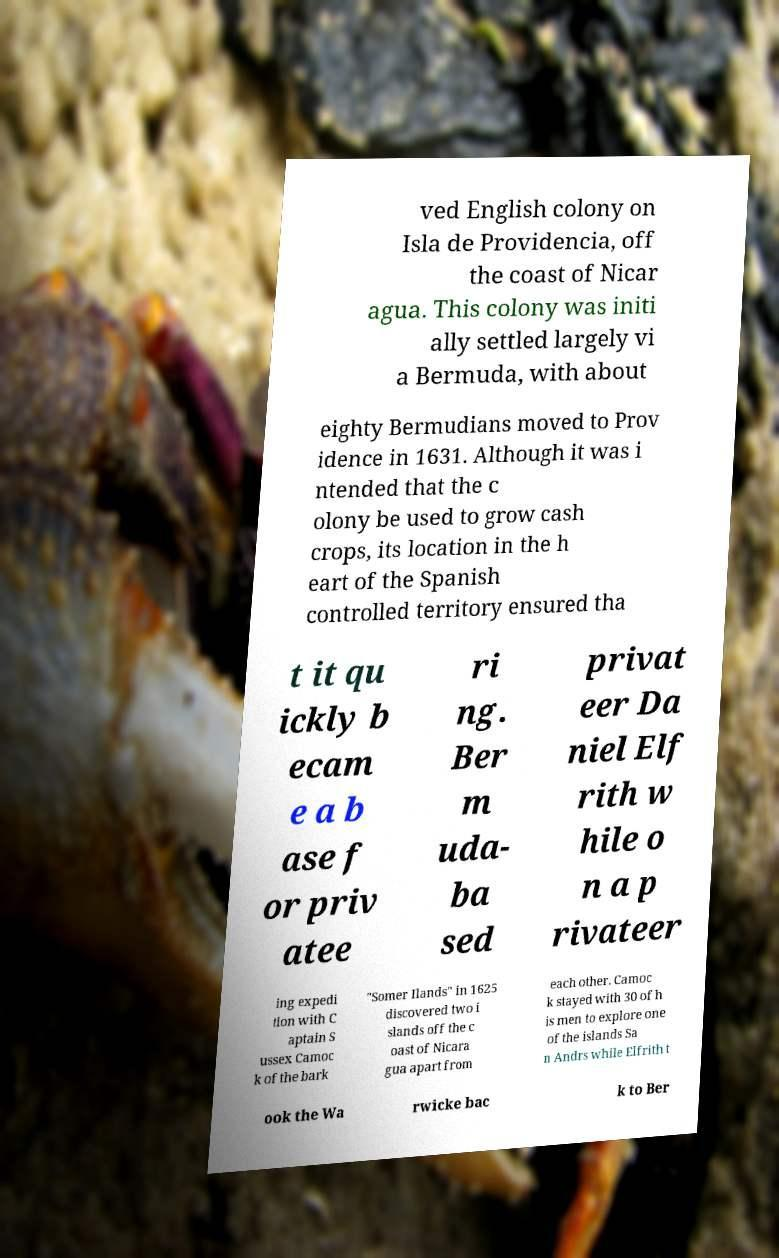Could you extract and type out the text from this image? ved English colony on Isla de Providencia, off the coast of Nicar agua. This colony was initi ally settled largely vi a Bermuda, with about eighty Bermudians moved to Prov idence in 1631. Although it was i ntended that the c olony be used to grow cash crops, its location in the h eart of the Spanish controlled territory ensured tha t it qu ickly b ecam e a b ase f or priv atee ri ng. Ber m uda- ba sed privat eer Da niel Elf rith w hile o n a p rivateer ing expedi tion with C aptain S ussex Camoc k of the bark "Somer Ilands" in 1625 discovered two i slands off the c oast of Nicara gua apart from each other. Camoc k stayed with 30 of h is men to explore one of the islands Sa n Andrs while Elfrith t ook the Wa rwicke bac k to Ber 